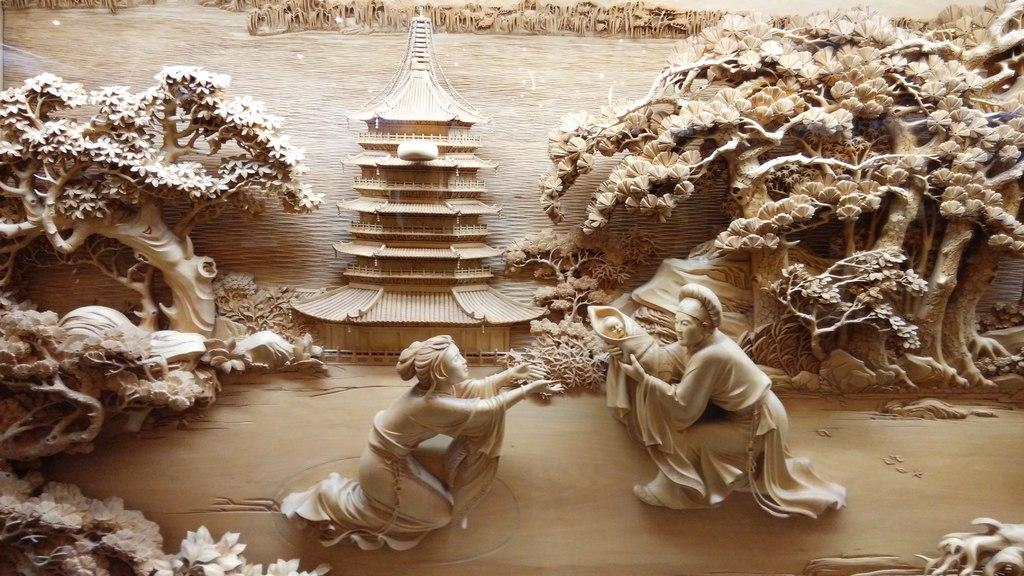What type of objects are depicted as sculptures in the image? There are sculptures of persons in the image. What natural elements can be seen in the image? There are trees, water, and grass visible in the image. What type of structures are present in the image? There are buildings in the image. Can you describe the time of day when the image was likely taken? The image was likely taken during the day, as there is sufficient light to see the details clearly. How many sheep are visible in the image? There are no sheep present in the image. What type of twig is being used to shake the sculptures in the image? There is no twig or shaking action depicted in the image; the sculptures are stationary. 